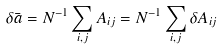<formula> <loc_0><loc_0><loc_500><loc_500>\delta \bar { a } = N ^ { - 1 } \sum _ { i , j } A _ { i j } = N ^ { - 1 } \sum _ { i , j } \delta A _ { i j }</formula> 